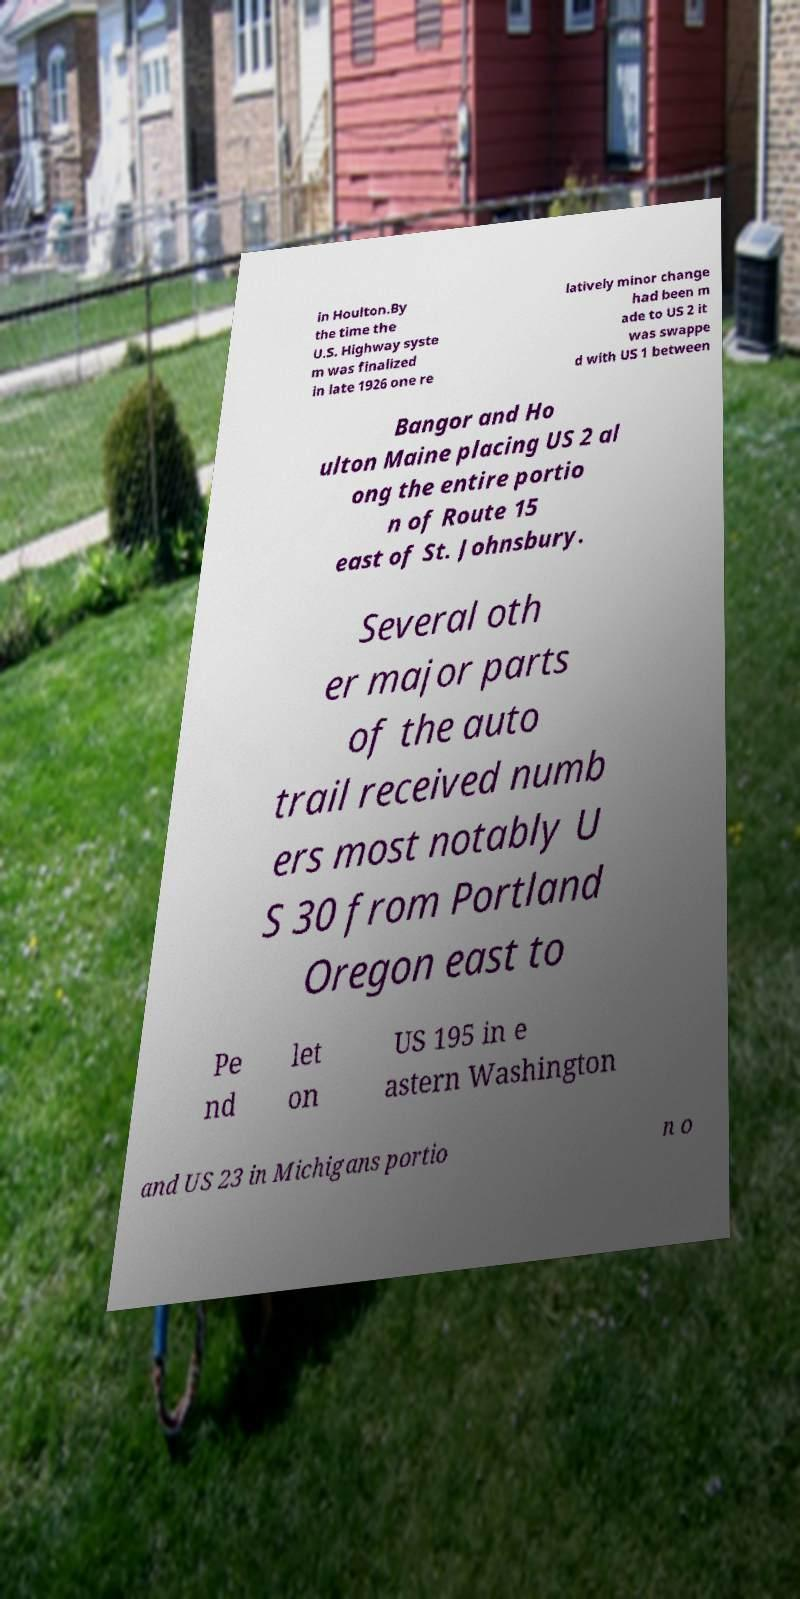For documentation purposes, I need the text within this image transcribed. Could you provide that? in Houlton.By the time the U.S. Highway syste m was finalized in late 1926 one re latively minor change had been m ade to US 2 it was swappe d with US 1 between Bangor and Ho ulton Maine placing US 2 al ong the entire portio n of Route 15 east of St. Johnsbury. Several oth er major parts of the auto trail received numb ers most notably U S 30 from Portland Oregon east to Pe nd let on US 195 in e astern Washington and US 23 in Michigans portio n o 